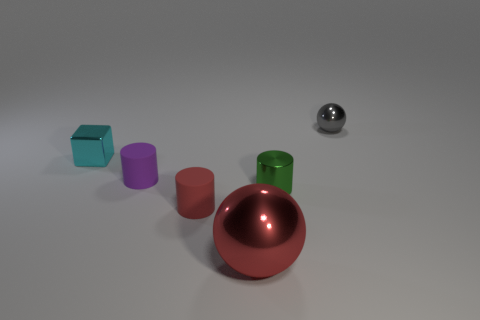How many cyan metallic things are the same size as the purple thing? 1 